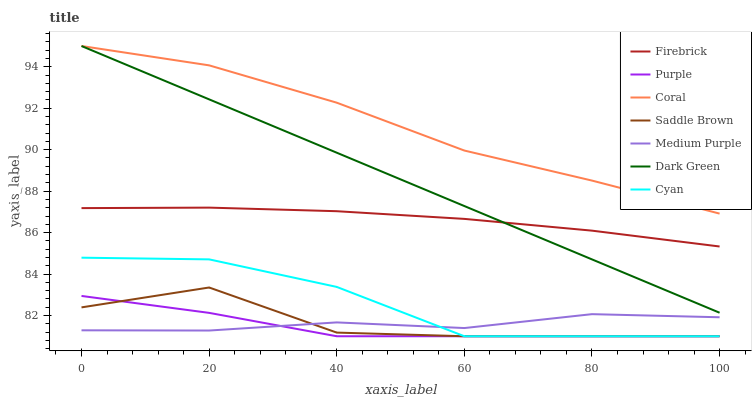Does Purple have the minimum area under the curve?
Answer yes or no. Yes. Does Coral have the maximum area under the curve?
Answer yes or no. Yes. Does Firebrick have the minimum area under the curve?
Answer yes or no. No. Does Firebrick have the maximum area under the curve?
Answer yes or no. No. Is Dark Green the smoothest?
Answer yes or no. Yes. Is Saddle Brown the roughest?
Answer yes or no. Yes. Is Firebrick the smoothest?
Answer yes or no. No. Is Firebrick the roughest?
Answer yes or no. No. Does Purple have the lowest value?
Answer yes or no. Yes. Does Firebrick have the lowest value?
Answer yes or no. No. Does Dark Green have the highest value?
Answer yes or no. Yes. Does Firebrick have the highest value?
Answer yes or no. No. Is Medium Purple less than Dark Green?
Answer yes or no. Yes. Is Coral greater than Medium Purple?
Answer yes or no. Yes. Does Coral intersect Dark Green?
Answer yes or no. Yes. Is Coral less than Dark Green?
Answer yes or no. No. Is Coral greater than Dark Green?
Answer yes or no. No. Does Medium Purple intersect Dark Green?
Answer yes or no. No. 